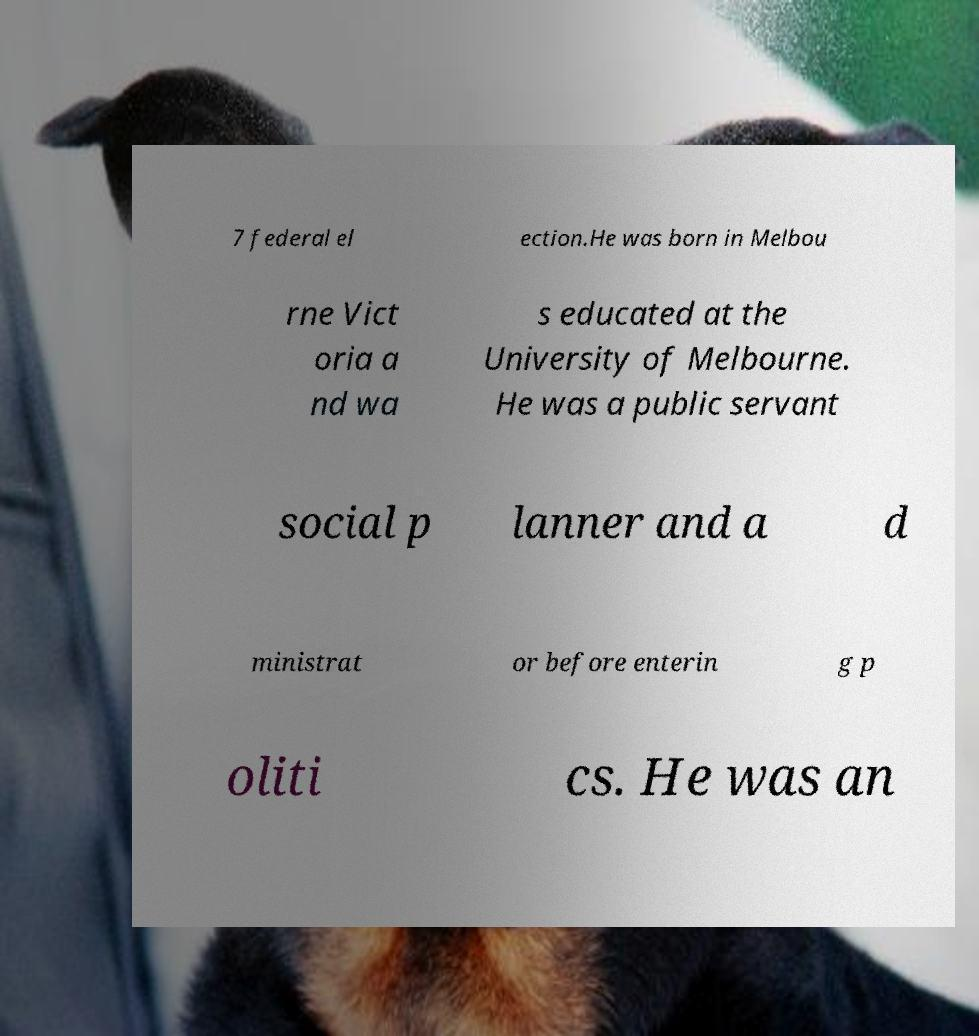Can you read and provide the text displayed in the image?This photo seems to have some interesting text. Can you extract and type it out for me? 7 federal el ection.He was born in Melbou rne Vict oria a nd wa s educated at the University of Melbourne. He was a public servant social p lanner and a d ministrat or before enterin g p oliti cs. He was an 